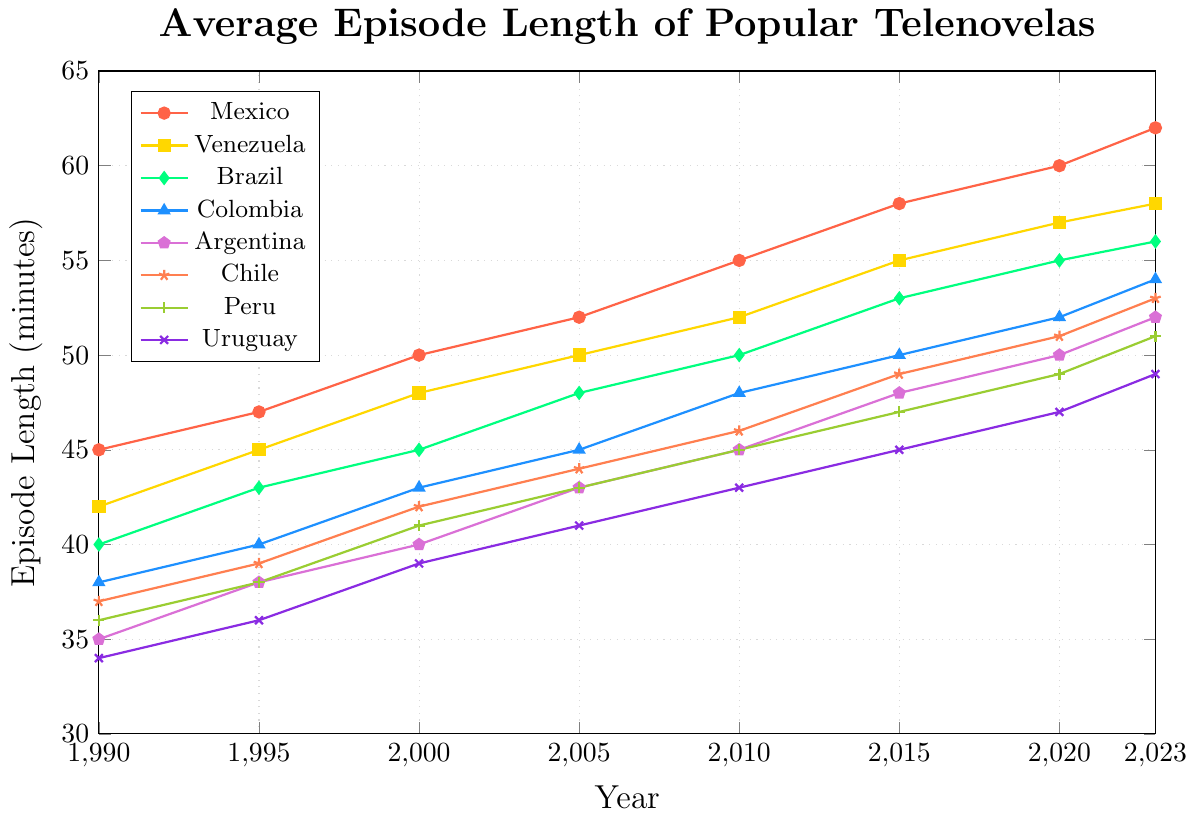Which country had the longest average episode length in 2023? From the chart, identify the highest data point in 2023 and the corresponding country.
Answer: Mexico Which country's average episode length increased the most from 1990 to 2023? Calculate the increase for each country by subtracting the 1990 value from the 2023 value. Mexico: 62 - 45 = 17, Venezuela: 58 - 42 = 16, Brazil: 56 - 40 = 16, etc. The highest increase is for Mexico with 17 minutes.
Answer: Mexico What was the average episode length for Argentina in 2000, and how does it compare to Chile in the same year? Locate the 2000 data points for Argentina and Chile from the chart. Argentina: 40, Chile: 42. Compare the two values.
Answer: Argentina: 40, Chile: 42 How did Venezuela's episode length change from 2010 to 2020? Subtract Venezuela's 2010 episode length from its 2020 episode length. 2020: 57, 2010: 52. The change is 57 - 52 = 5 minutes.
Answer: Increased by 5 minutes Which country had the shortest average episode length in 1995? From the chart, identify the lowest data point in 1995 and the corresponding country.
Answer: Uruguay By how much did Colombia's average episode length increase from 1990 to 2015? Subtract Colombia's 1990 episode length from its 2015 episode length. 2015: 50, 1990: 38. The increase is 50 - 38 = 12 minutes.
Answer: 12 minutes Which two countries had the same average episode length in 2010? From the chart, identify any data points in 2010 that are equal. Both Venezuela and Colombia have the same value of 48 minutes.
Answer: Venezuela and Colombia What is the trend of Brazil's average episode length from 1990 to 2023, and how does it compare with Peru's trend? Observe the trend of the lines for Brazil and Peru. Brazil shows a consistent upward trend. Peru also shows an upward trend, but not as steep. Both countries show an increasing trend, but Brazil has a higher overall increase.
Answer: Both increasing, Brazil's increase is steeper Which country had the closest average episode length to 50 minutes in the year 2015? From the chart, identify the data points in 2015 closest to 50 minutes. Colombia and Brazil are both very close, with 50 and 53 minutes, respectively, but Colombia is exactly 50 minutes.
Answer: Colombia 